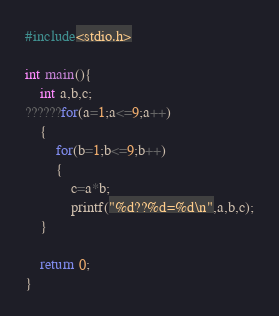<code> <loc_0><loc_0><loc_500><loc_500><_C_>#include<stdio.h>

int main(){
    int a,b,c;
??????for(a=1;a<=9;a++)
    {
        for(b=1;b<=9;b++)
        {
            c=a*b;
            printf("%d??%d=%d\n",a,b,c);
	}

    return 0;
}</code> 